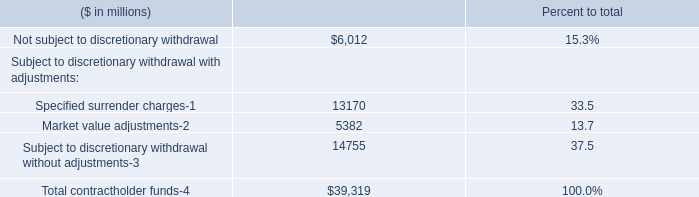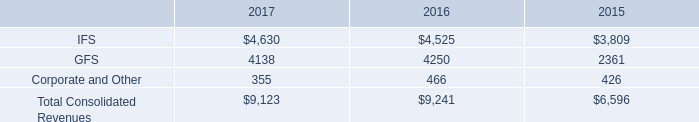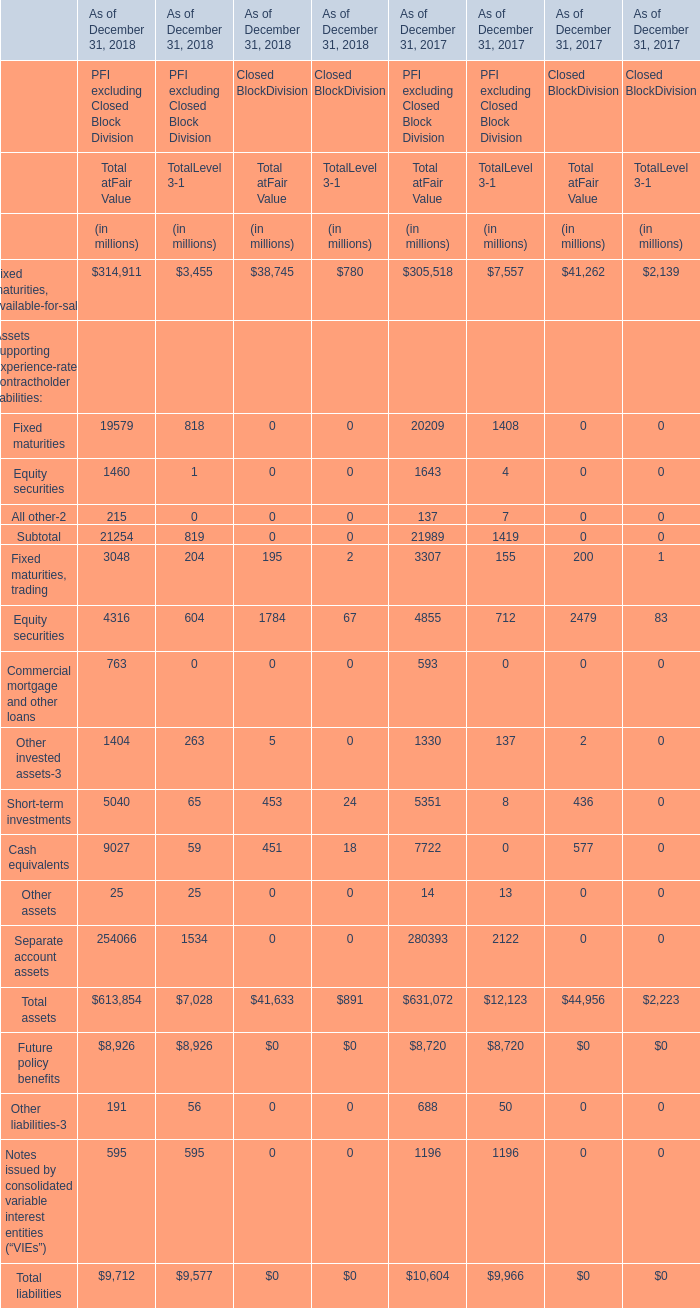What is the value of the Total at Fair Value in terms of Closed Block Division for Total assets as of December 31, 2018? (in million) 
Answer: 41633. 